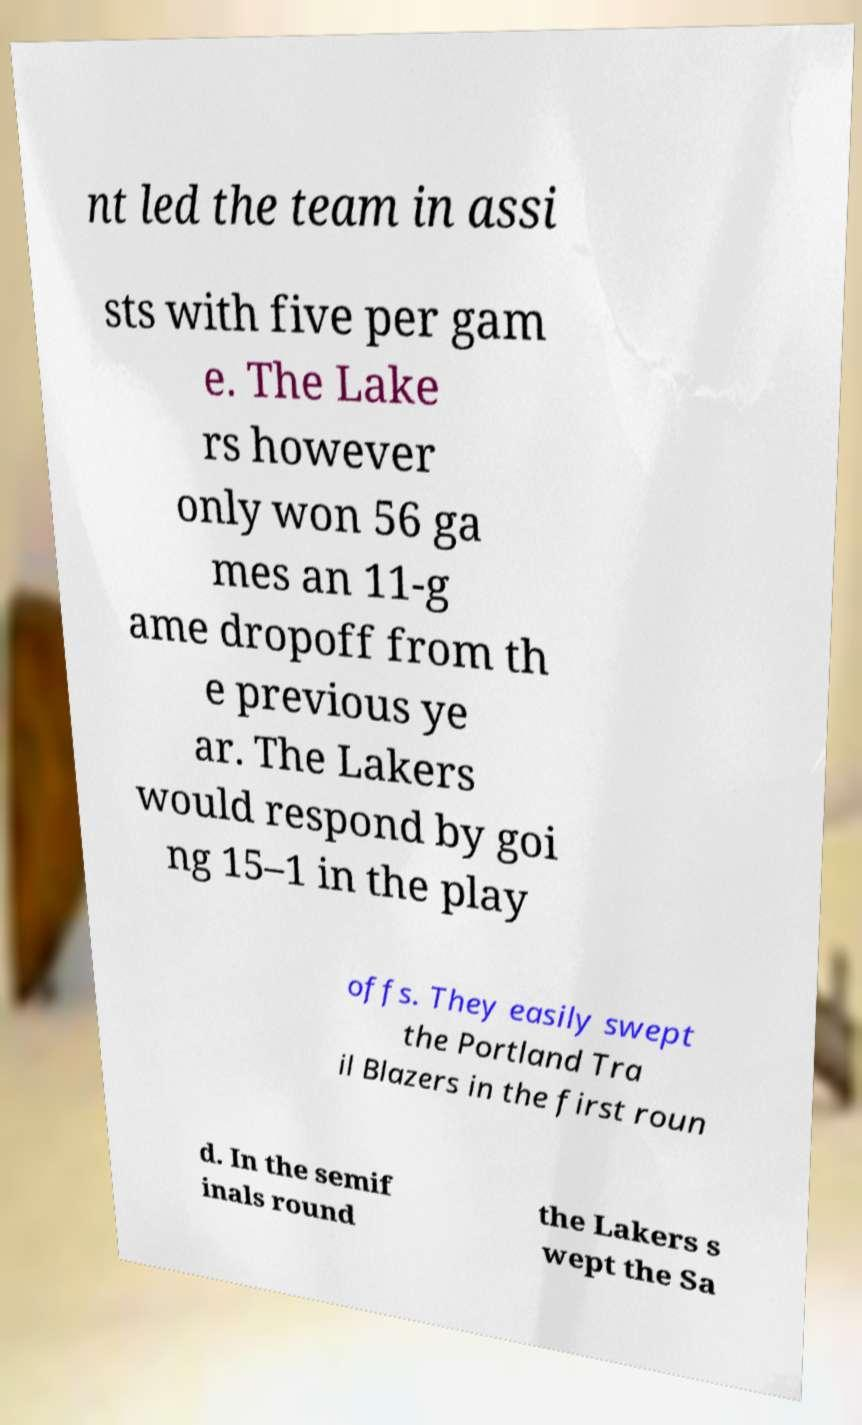What messages or text are displayed in this image? I need them in a readable, typed format. nt led the team in assi sts with five per gam e. The Lake rs however only won 56 ga mes an 11-g ame dropoff from th e previous ye ar. The Lakers would respond by goi ng 15–1 in the play offs. They easily swept the Portland Tra il Blazers in the first roun d. In the semif inals round the Lakers s wept the Sa 